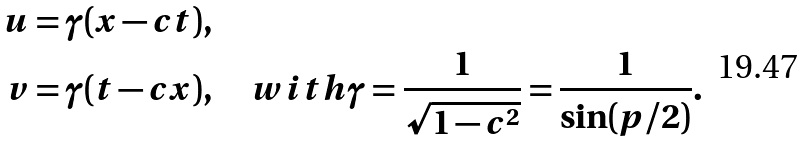Convert formula to latex. <formula><loc_0><loc_0><loc_500><loc_500>u & = \gamma ( x - c t ) , \\ v & = \gamma ( t - c x ) , \quad w i t h \gamma = \frac { 1 } { \sqrt { 1 - c ^ { 2 } } } = \frac { 1 } { \sin ( p / 2 ) } .</formula> 